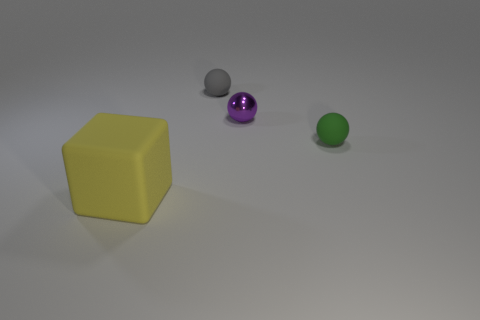Subtract all gray matte spheres. How many spheres are left? 2 Add 4 matte objects. How many objects exist? 8 Subtract all gray balls. How many balls are left? 2 Subtract 0 cyan cylinders. How many objects are left? 4 Subtract all cubes. How many objects are left? 3 Subtract 1 spheres. How many spheres are left? 2 Subtract all blue spheres. Subtract all gray blocks. How many spheres are left? 3 Subtract all purple cylinders. How many purple spheres are left? 1 Subtract all purple balls. Subtract all tiny green rubber balls. How many objects are left? 2 Add 4 yellow rubber things. How many yellow rubber things are left? 5 